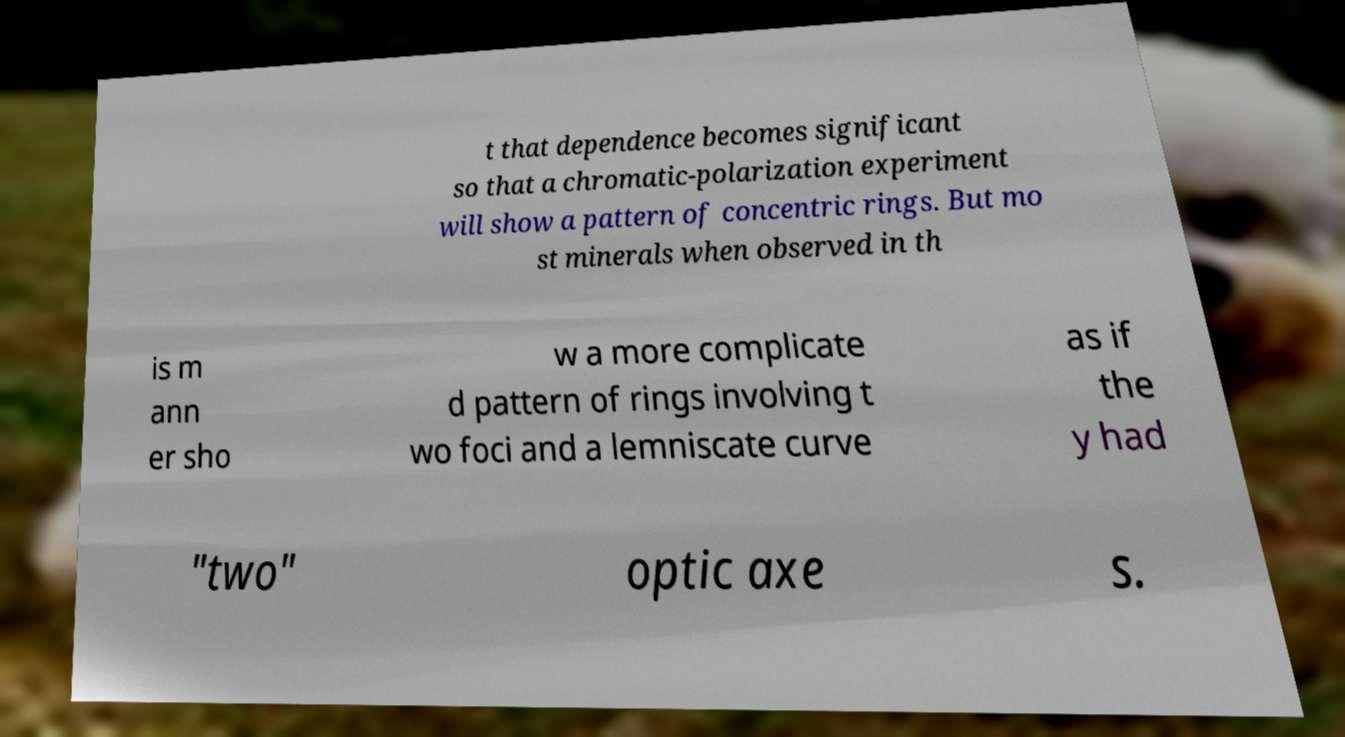Can you accurately transcribe the text from the provided image for me? t that dependence becomes significant so that a chromatic-polarization experiment will show a pattern of concentric rings. But mo st minerals when observed in th is m ann er sho w a more complicate d pattern of rings involving t wo foci and a lemniscate curve as if the y had "two" optic axe s. 